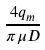Convert formula to latex. <formula><loc_0><loc_0><loc_500><loc_500>\frac { 4 q _ { m } } { \pi \mu D }</formula> 